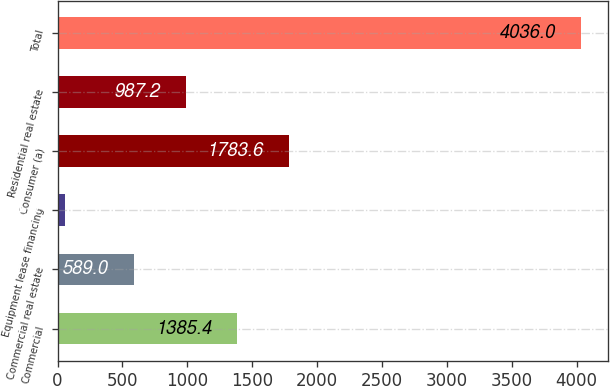<chart> <loc_0><loc_0><loc_500><loc_500><bar_chart><fcel>Commercial<fcel>Commercial real estate<fcel>Equipment lease financing<fcel>Consumer (a)<fcel>Residential real estate<fcel>Total<nl><fcel>1385.4<fcel>589<fcel>54<fcel>1783.6<fcel>987.2<fcel>4036<nl></chart> 